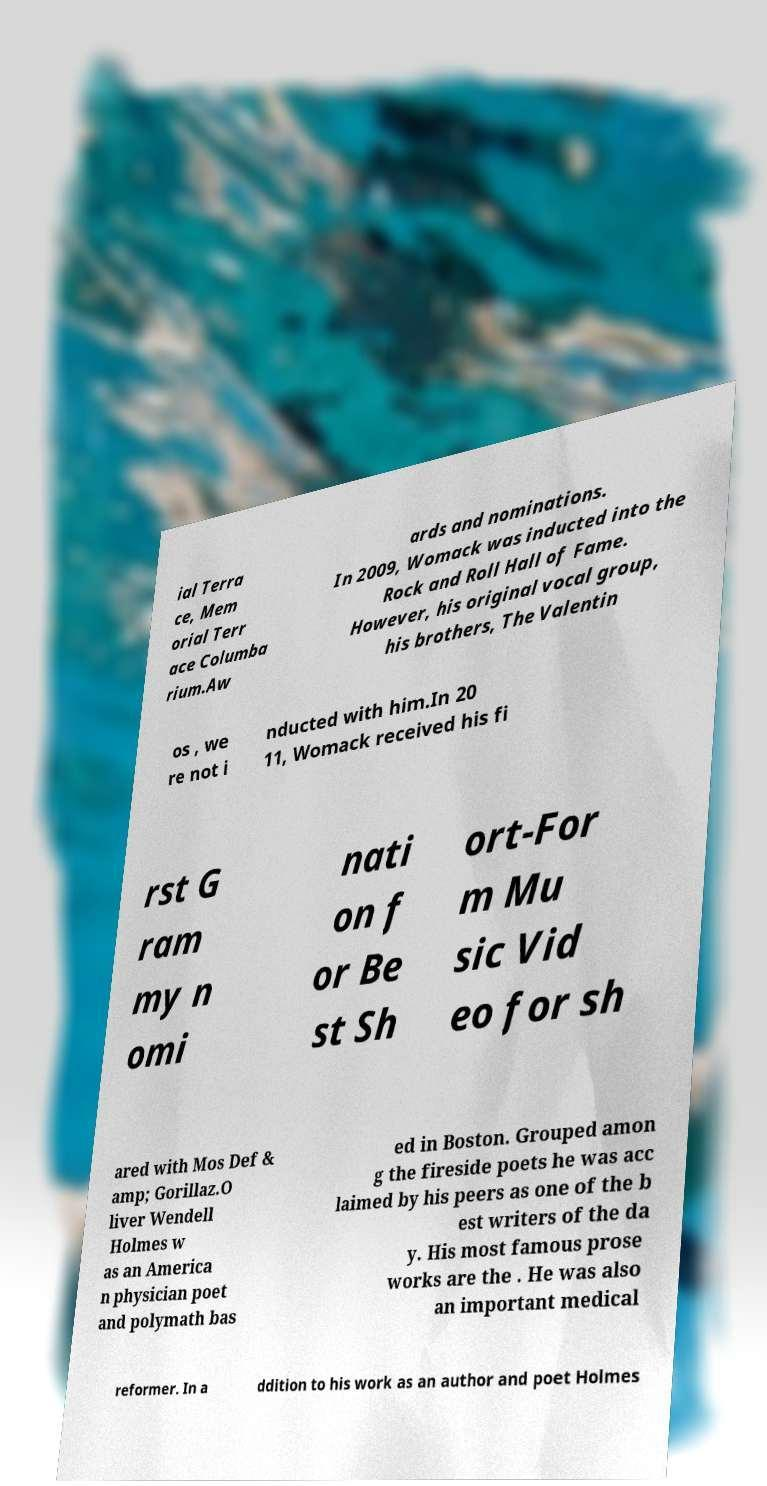Please identify and transcribe the text found in this image. ial Terra ce, Mem orial Terr ace Columba rium.Aw ards and nominations. In 2009, Womack was inducted into the Rock and Roll Hall of Fame. However, his original vocal group, his brothers, The Valentin os , we re not i nducted with him.In 20 11, Womack received his fi rst G ram my n omi nati on f or Be st Sh ort-For m Mu sic Vid eo for sh ared with Mos Def & amp; Gorillaz.O liver Wendell Holmes w as an America n physician poet and polymath bas ed in Boston. Grouped amon g the fireside poets he was acc laimed by his peers as one of the b est writers of the da y. His most famous prose works are the . He was also an important medical reformer. In a ddition to his work as an author and poet Holmes 